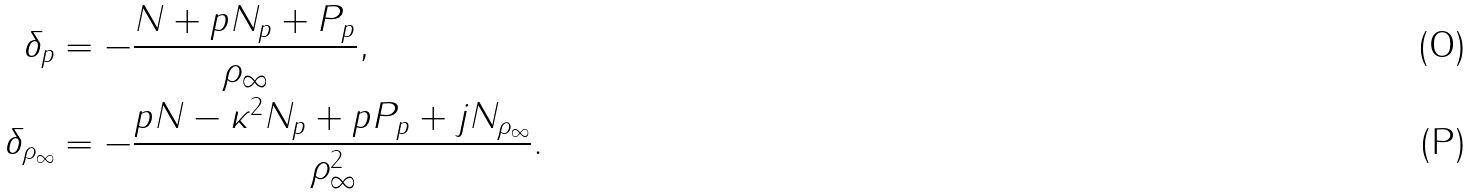<formula> <loc_0><loc_0><loc_500><loc_500>\delta _ { p } & = - \frac { N + p N _ { p } + P _ { p } } { \rho _ { \infty } } , \\ \delta _ { \rho _ { \infty } } & = - \frac { p N - \kappa ^ { 2 } N _ { p } + p P _ { p } + j N _ { \rho _ { \infty } } } { \rho _ { \infty } ^ { 2 } } .</formula> 